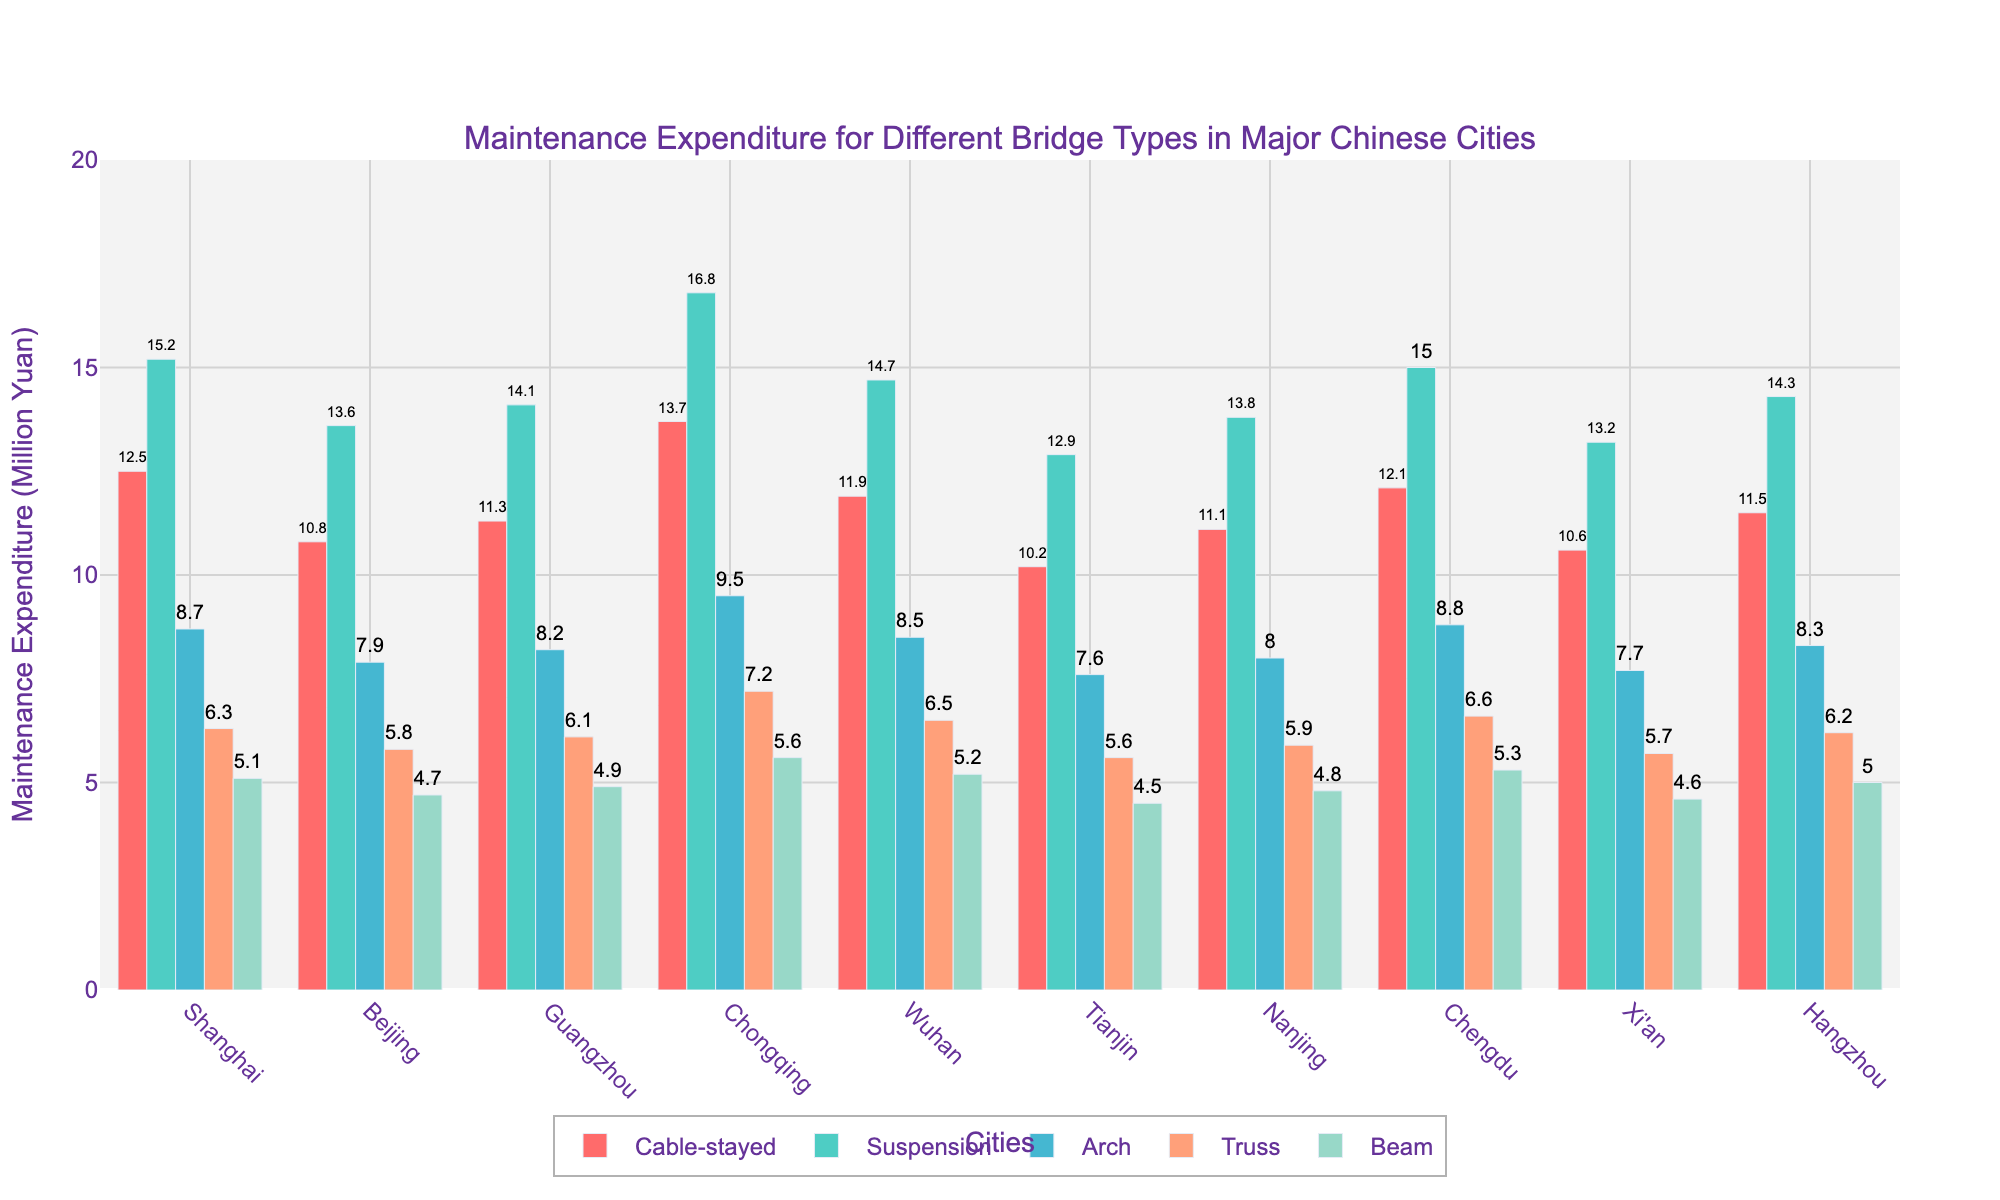What is the city with the highest maintenance expenditure on suspension bridges? The bar for Chongqing in the suspension bridge category is the tallest amongst all cities, indicating the highest expenditure.
Answer: Chongqing Which bridge type in Shanghai has the lowest maintenance expenditure and what is its value? Comparing the heights of the bars in Shanghai, the bar representing Beam bridges is the shortest.
Answer: Beam, 5.1 million Yuan How much more does Guangzhou spend on arch bridges compared to Beijing? The expenditure for arch bridges in Guangzhou is 8.2 million Yuan and in Beijing, it is 7.9 million Yuan. The difference is 8.2 - 7.9.
Answer: 0.3 million Yuan Which city has the smallest overall maintenance expenditure for Truss bridges? By comparing the heights of the bars for Truss bridges across all cities, Tianjin has the shortest bar, representing the smallest expenditure.
Answer: Tianjin What is the highest value of maintenance expenditure for a single bridge type in the dataset and which city and bridge type does it correspond to? The highest bar in the figure corresponds to Suspension bridges in Chongqing, with a value of 16.8 million Yuan.
Answer: Chongqing, Suspension, 16.8 million Yuan What is the combined maintenance expenditure for Cable-stayed bridges in Nanjing and Chengdu? The maintenance expenditure for Cable-stayed bridges is 11.1 million Yuan in Nanjing and 12.1 million Yuan in Chengdu. The total is 11.1 + 12.1.
Answer: 23.2 million Yuan How does the expenditure on Beam bridges in Hangzhou compare to that in Wuhan? The height indicating the expenditure on Beam bridges in Hangzhou (5.0) is slightly lower compared to that in Wuhan (5.2).
Answer: Hangzhou's expenditure is slightly less What is the average maintenance expenditure on Arch bridges across all cities? Summing up the expenditures for Arch bridges: 8.7 + 7.9 + 8.2 + 9.5 + 8.5 + 7.6 + 8.0 + 8.8 + 7.7 + 8.3 = 83.2, then dividing by the number of cities (10). The average is 83.2 / 10.
Answer: 8.32 million Yuan Which city has the most consistent (smallest range) maintenance expenditure across all bridge types? For each city, calculating the range (highest expenditure - lowest expenditure): Shanghai (15.2 - 5.1), Beijing (13.6 - 4.7), Guangzhou (14.1 - 4.9), Chongqing (16.8 - 5.6), Wuhan (14.7 - 5.2), Tianjin (12.9 - 4.5), Nanjing (13.8 - 4.8), Chengdu (15.0 - 5.3), Xi'an (13.2 - 4.6), Hangzhou (14.3 - 5.0). Tianjin has the smallest range: 12.9 - 4.5 = 8.4.
Answer: Tianjin 